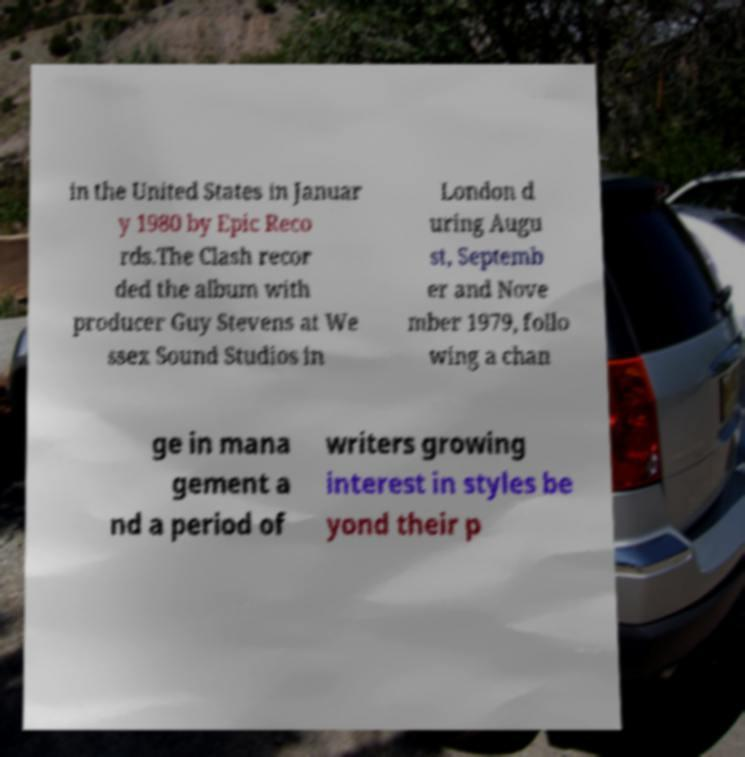For documentation purposes, I need the text within this image transcribed. Could you provide that? in the United States in Januar y 1980 by Epic Reco rds.The Clash recor ded the album with producer Guy Stevens at We ssex Sound Studios in London d uring Augu st, Septemb er and Nove mber 1979, follo wing a chan ge in mana gement a nd a period of writers growing interest in styles be yond their p 